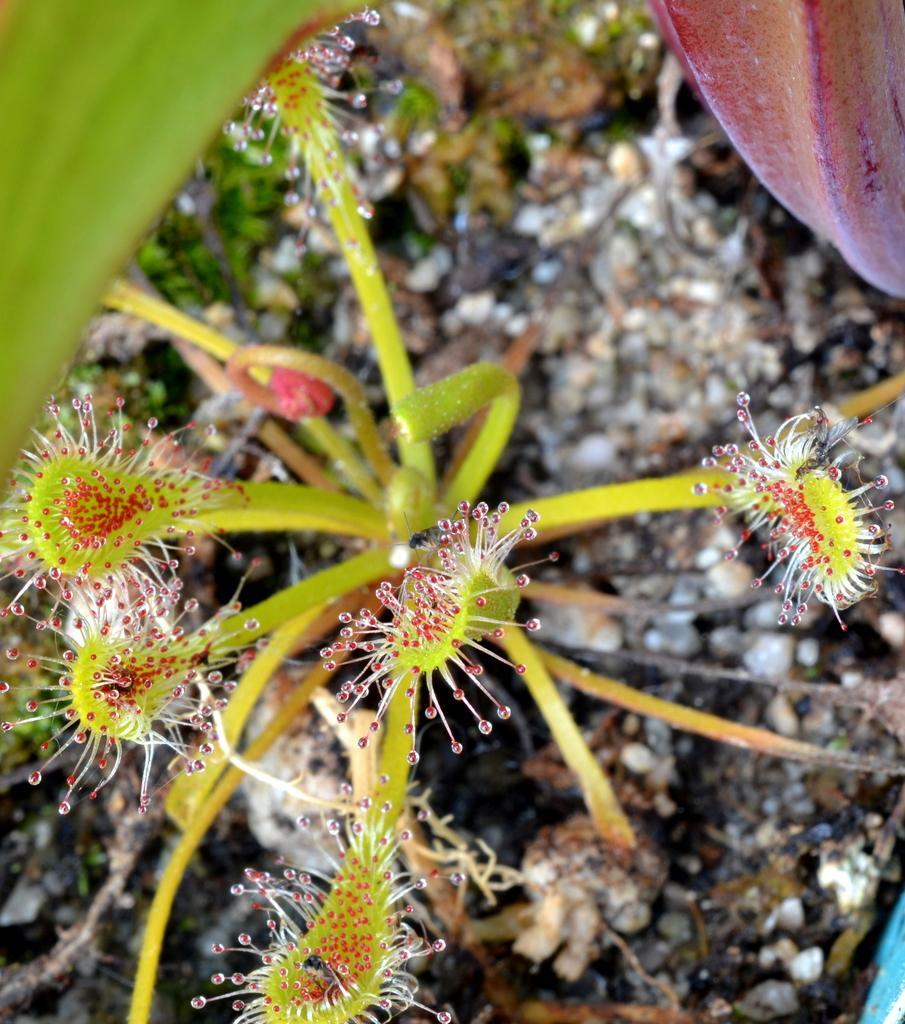Can you describe this image briefly? In this image in the foreground there is one plant, and in the background there is scrap. At the top there are some leaves. 